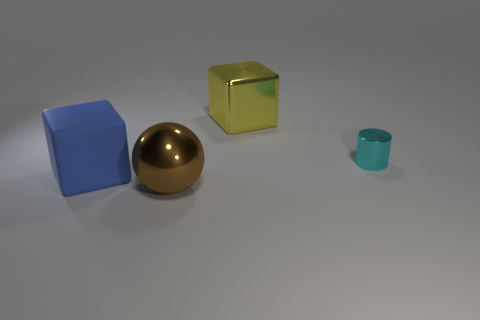Is there any indication of movement or are all objects stationary? All the objects in the image are stationary, with no indication of movement or intention to suggest that they've been in motion. They are set against a static backdrop, which reinforces the stillness of the scene. Could you infer anything about the purpose of this arrangement? The arrangement of these objects does not immediately suggest a practical purpose. It might be an artistic composition, an experimental setup to study the properties of shapes and materials under consistent lighting, or could simply be a display with no specific intent beyond visual aesthetics. 